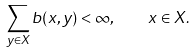Convert formula to latex. <formula><loc_0><loc_0><loc_500><loc_500>\sum _ { y \in X } b ( x , y ) < \infty , \quad x \in X .</formula> 